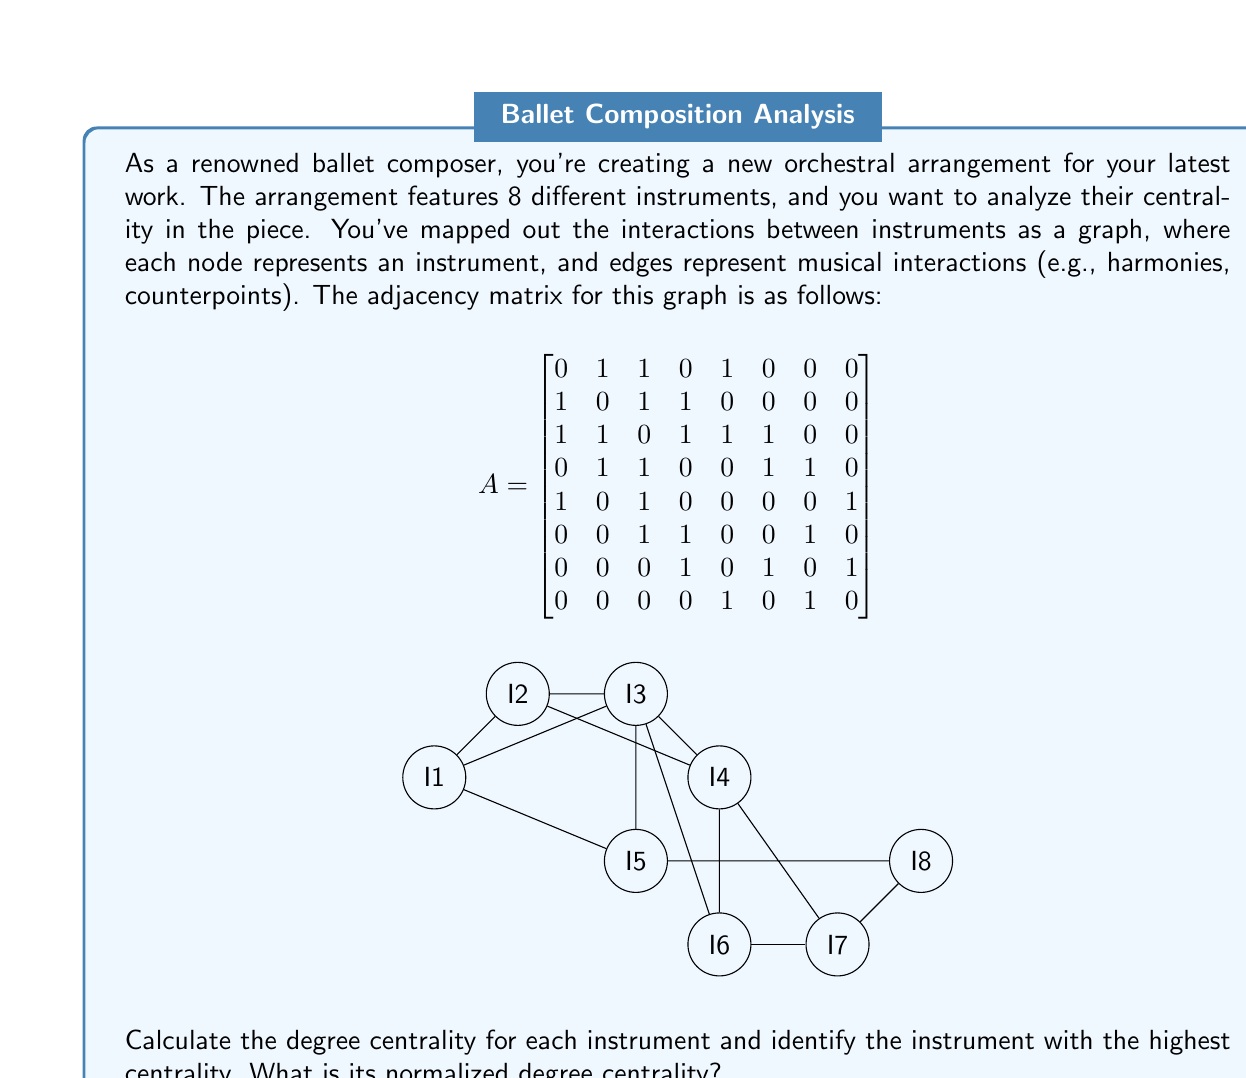Can you answer this question? To solve this problem, we'll follow these steps:

1) Calculate the degree centrality for each instrument (node).
2) Identify the instrument with the highest centrality.
3) Calculate the normalized degree centrality for that instrument.

Step 1: Calculating degree centrality

The degree centrality of a node is the number of edges connected to it. In an adjacency matrix, this is the sum of the row (or column, as the matrix is symmetric) for each node.

$C_D(I_1) = 3$
$C_D(I_2) = 3$
$C_D(I_3) = 5$
$C_D(I_4) = 4$
$C_D(I_5) = 3$
$C_D(I_6) = 3$
$C_D(I_7) = 3$
$C_D(I_8) = 2$

Step 2: Identifying the instrument with highest centrality

The instrument with the highest degree centrality is I3 with a degree of 5.

Step 3: Calculating normalized degree centrality

The normalized degree centrality is calculated as:

$$C'_D(v) = \frac{C_D(v)}{n-1}$$

where $C_D(v)$ is the degree of the node and $n$ is the total number of nodes.

For I3:
$$C'_D(I_3) = \frac{5}{8-1} = \frac{5}{7} \approx 0.7143$$

Therefore, the normalized degree centrality of the most central instrument (I3) is $\frac{5}{7}$ or approximately 0.7143.
Answer: $\frac{5}{7}$ 